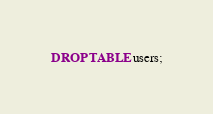<code> <loc_0><loc_0><loc_500><loc_500><_SQL_>DROP TABLE users;</code> 